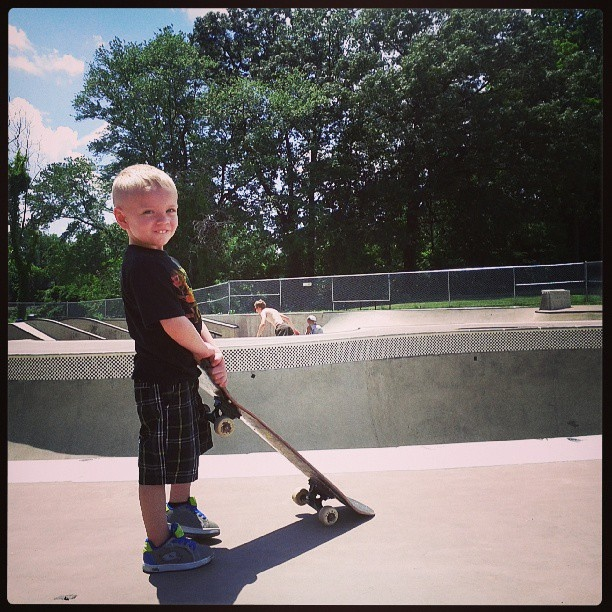Describe the objects in this image and their specific colors. I can see people in black, brown, gray, and lightgray tones, skateboard in black, gray, and darkgray tones, people in black, lightgray, tan, darkgray, and gray tones, and people in black, darkgray, lightgray, gray, and brown tones in this image. 